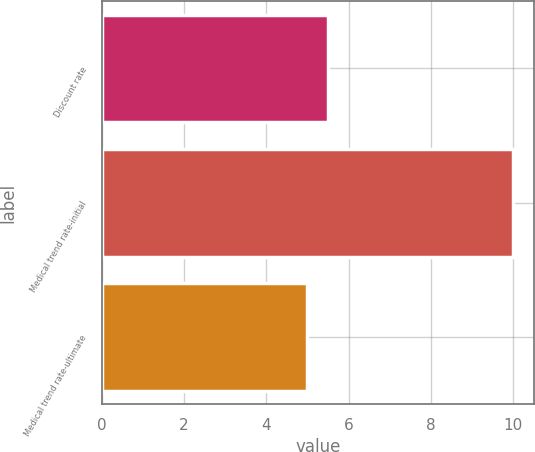<chart> <loc_0><loc_0><loc_500><loc_500><bar_chart><fcel>Discount rate<fcel>Medical trend rate-initial<fcel>Medical trend rate-ultimate<nl><fcel>5.5<fcel>10<fcel>5<nl></chart> 